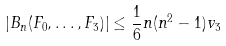<formula> <loc_0><loc_0><loc_500><loc_500>| B _ { n } ( F _ { 0 } , \dots , F _ { 3 } ) | \leq \frac { 1 } { 6 } n ( n ^ { 2 } - 1 ) v _ { 3 }</formula> 